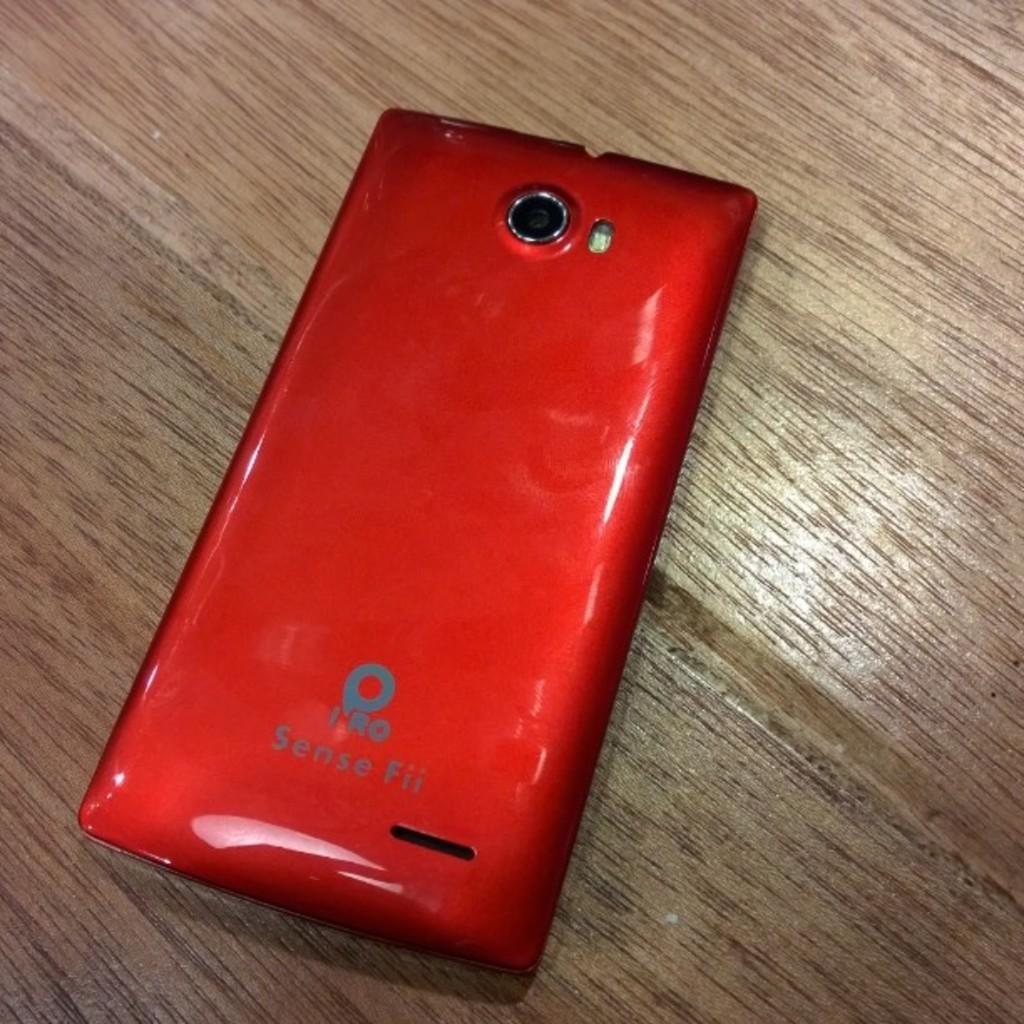<image>
Provide a brief description of the given image. Red cell hone that says IRO in the back on top of a table. 